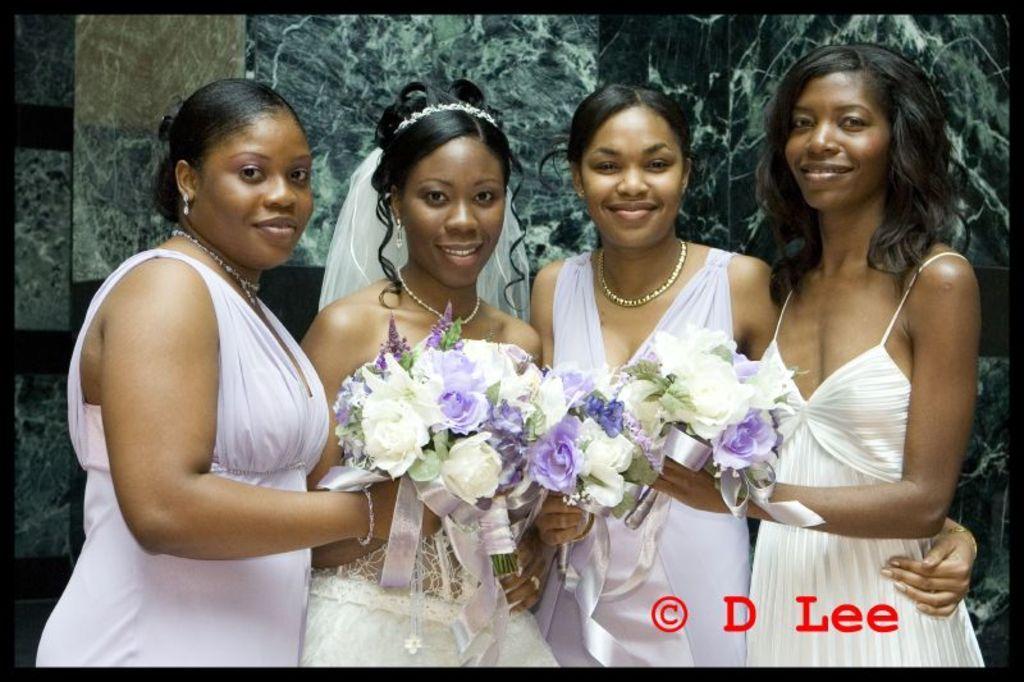Please provide a concise description of this image. In this image we can see group of women standing and holding a bouquets. In the background there is a wall. At the bottom there is a text. 